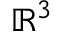Convert formula to latex. <formula><loc_0><loc_0><loc_500><loc_500>\mathbb { R } ^ { 3 }</formula> 